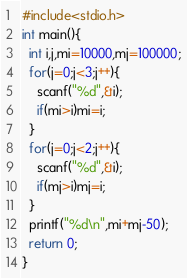Convert code to text. <code><loc_0><loc_0><loc_500><loc_500><_C_>#include<stdio.h>
int main(){
  int i,j,mi=10000,mj=100000;
  for(j=0;j<3;j++){
    scanf("%d",&i);
    if(mi>i)mi=i;
  }
  for(j=0;j<2;j++){
    scanf("%d",&i);
    if(mj>i)mj=i;
  }
  printf("%d\n",mi+mj-50);
  return 0;
}</code> 